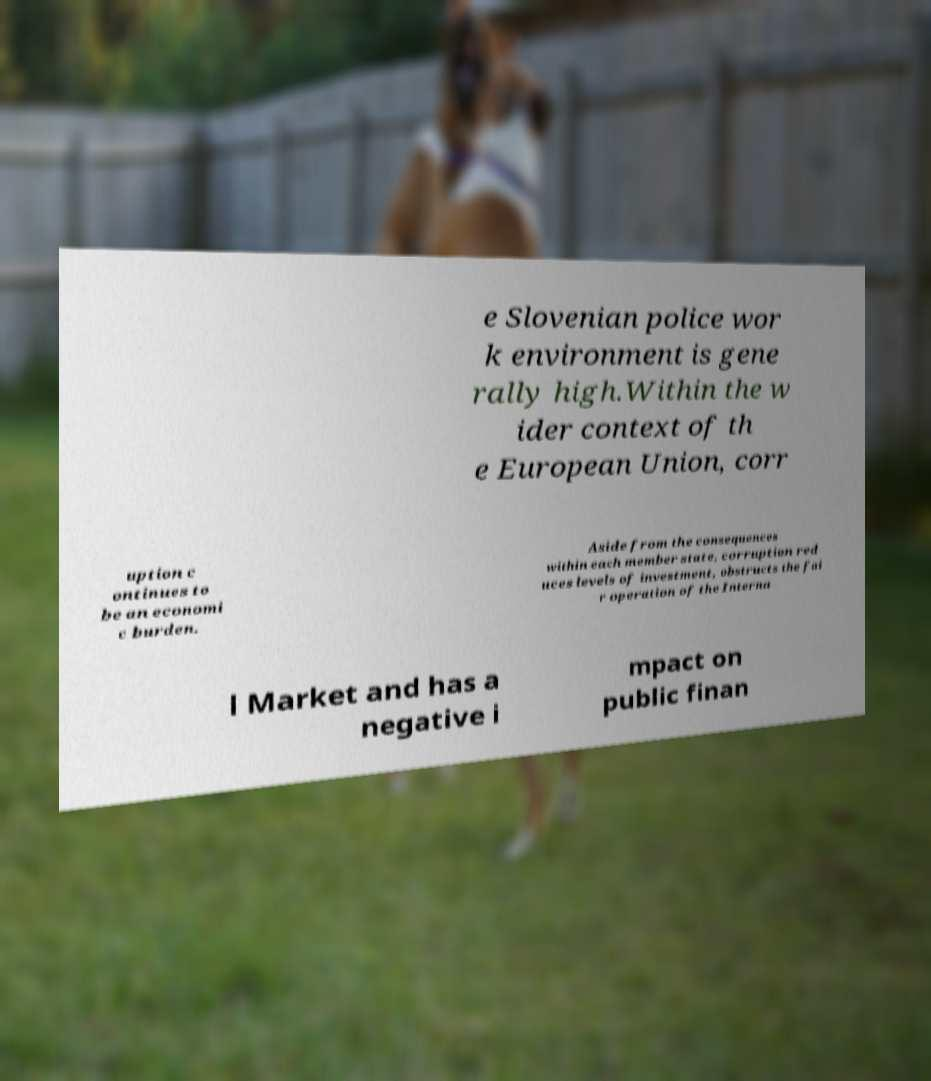For documentation purposes, I need the text within this image transcribed. Could you provide that? e Slovenian police wor k environment is gene rally high.Within the w ider context of th e European Union, corr uption c ontinues to be an economi c burden. Aside from the consequences within each member state, corruption red uces levels of investment, obstructs the fai r operation of the Interna l Market and has a negative i mpact on public finan 